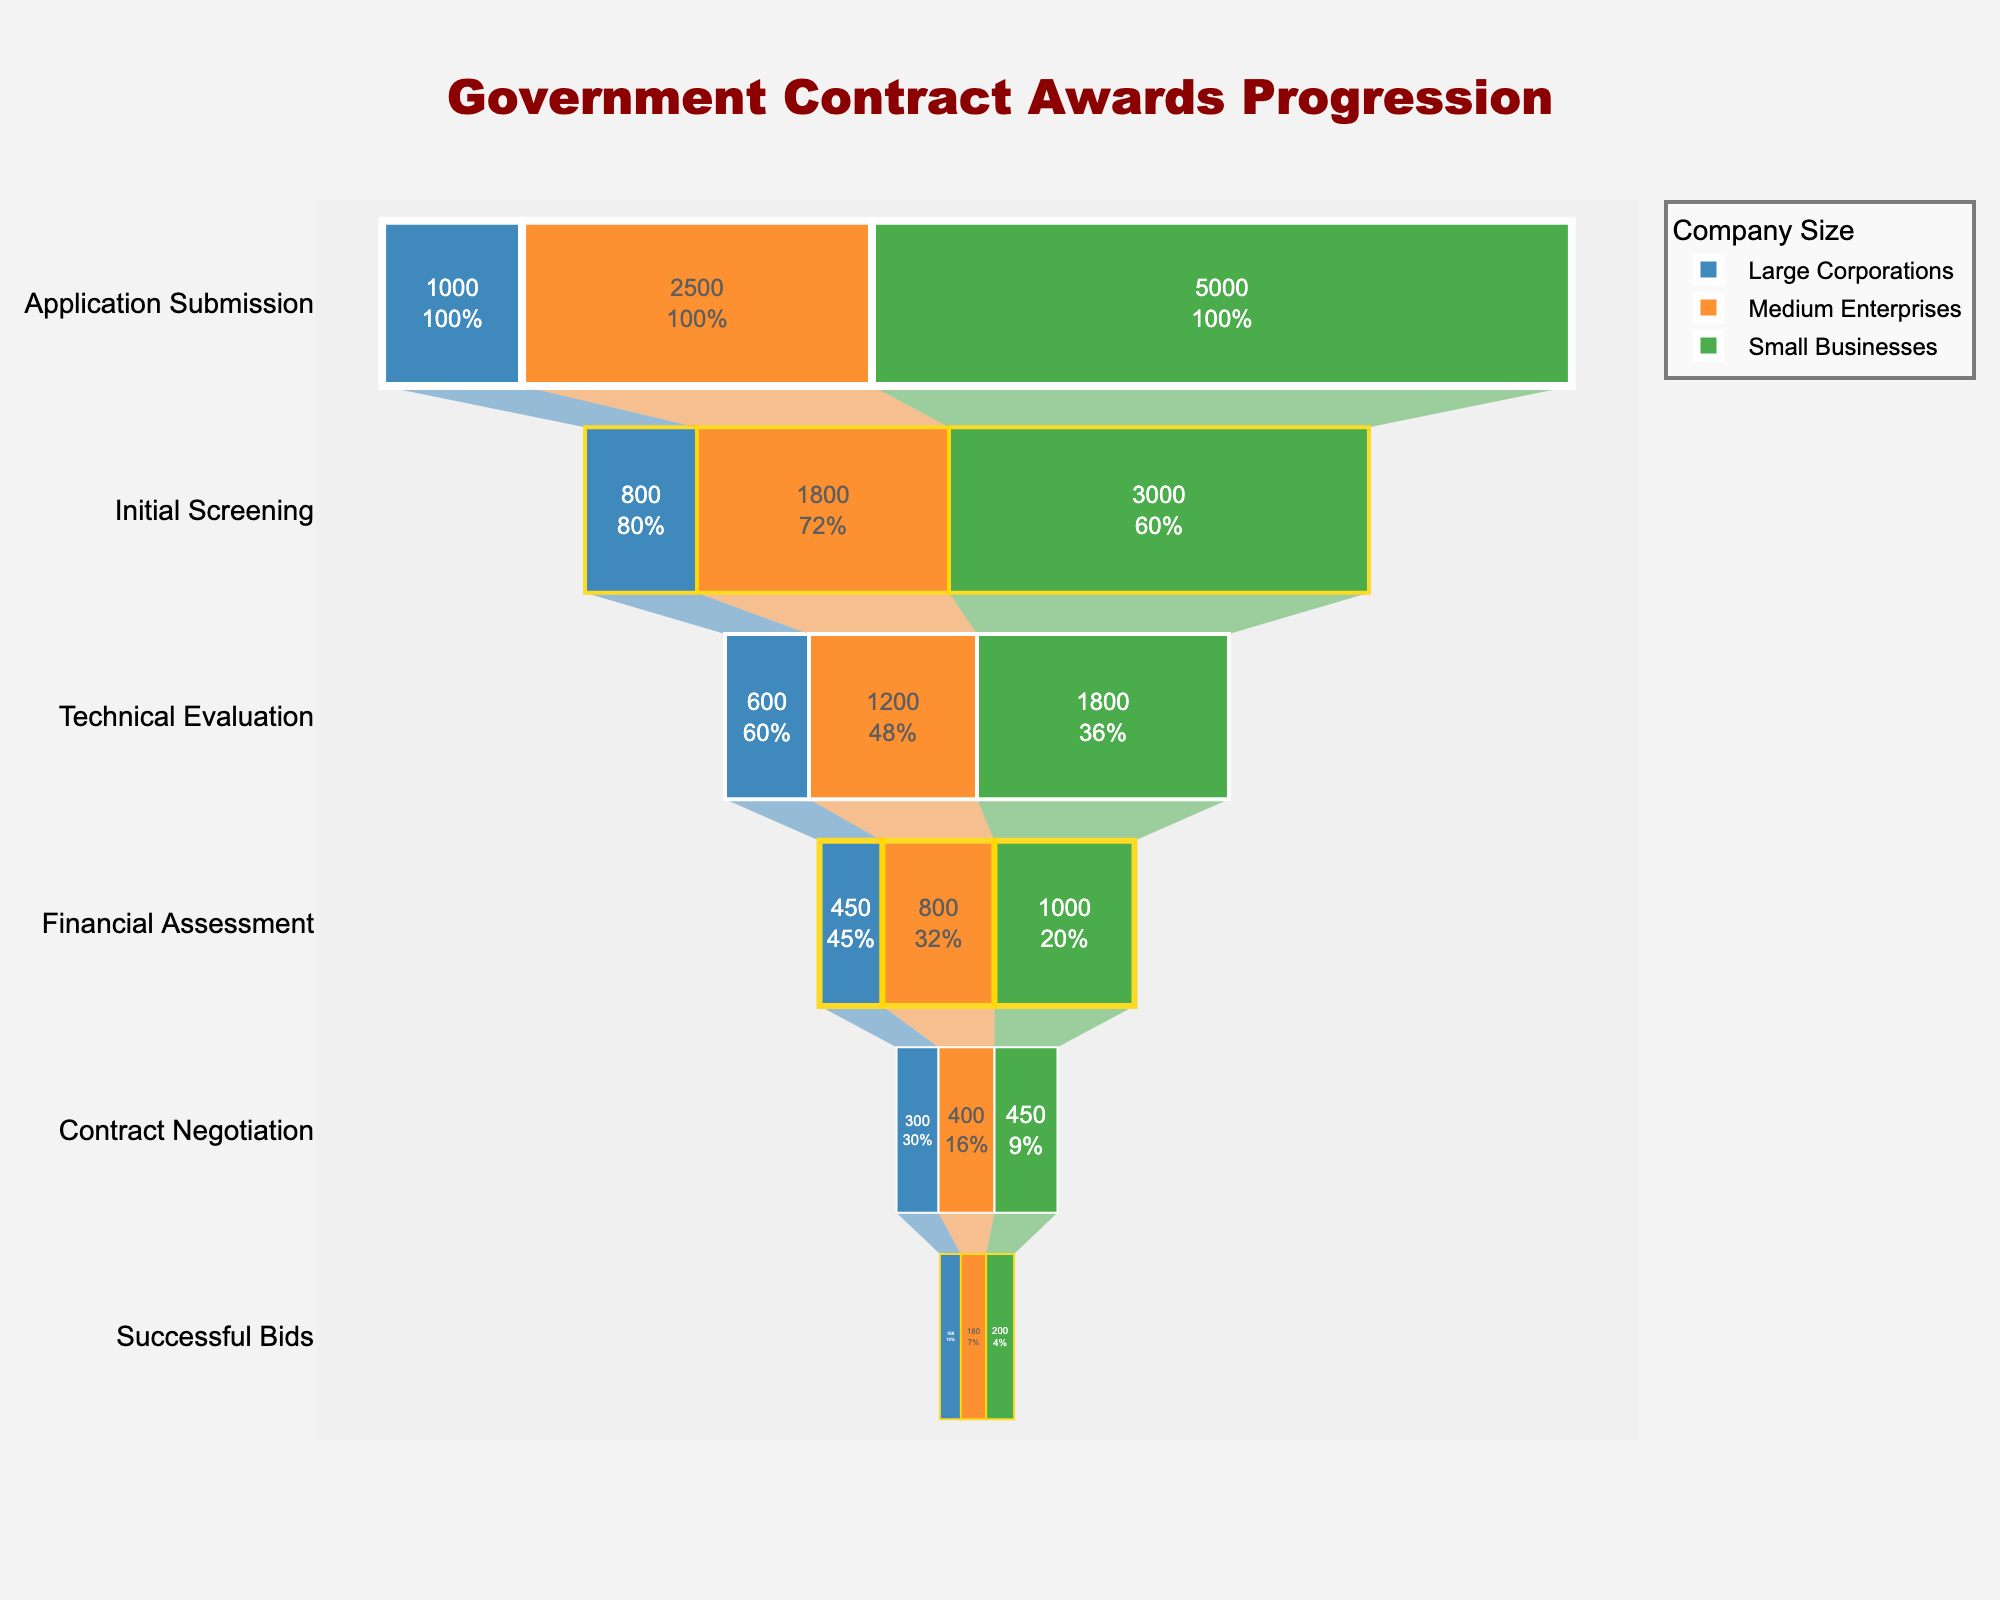What is the title of the figure? The title of the figure is displayed at the top of the chart and reads "Government Contract Awards Progression" as mentioned in the configuration details.
Answer: Government Contract Awards Progression How many stages are displayed in the funnel chart? By observing the figure, we can see there are six stages displayed in the funnel: Application Submission, Initial Screening, Technical Evaluation, Financial Assessment, Contract Negotiation, and Successful Bids.
Answer: Six Which company size has the highest number of successful bids? To find this, we look at the bottom part of the funnel chart where "Successful Bids" are listed. The numbers for Large Corporations (150), Medium Enterprises (180), and Small Businesses (200) indicate that Small Businesses have the highest number of successful bids.
Answer: Small Businesses What percentage of Large Corporations' applications make it to the contract negotiation stage? First, find the number of applications submitted by Large Corporations (1000). Then look at the number that makes it to the "Contract Negotiation" stage (300). The percentage is calculated by (300 / 1000) * 100%.
Answer: 30% How many applications submitted by Medium Enterprises are screened out during the Initial Screening stage? Medium Enterprises submit 2500 applications and 1800 pass the Initial Screening. The number of applications screened out is 2500 - 1800.
Answer: 700 What is the ratio of successful bids to financial assessments for Small Businesses? Look at the numbers for Small Businesses at the "Financial Assessment" stage (1000) and "Successful Bids" stage (200). The ratio is 200 to 1000, which simplifies to 1:5.
Answer: 1:5 How many stages see a greater than 50% reduction in the number of applications for Large Corporations? Calculate the reduction percentage between each pair of successive stages for Large Corporations:  
   - Application Submission -> Initial Screening: (1000 - 800) / 1000 = 20%
   - Initial Screening -> Technical Evaluation: (800 - 600) / 800 = 25%
   - Technical Evaluation -> Financial Assessment: (600 - 450) / 600 = 25%
   - Financial Assessment -> Contract Negotiation: (450 - 300) / 450 = 33%
   - Contract Negotiation -> Successful Bids: (300 - 150) / 300 = 50%  
   Only the transition from Contract Negotiation to Successful Bids sees exactly a 50% reduction, so no transitions see a greater than 50% reduction.
Answer: Zero Between Technical Evaluation and Contract Negotiation stages, which company size has the highest drop-off in absolute numbers? Calculate the drop-off for each company:  
   - Large Corporations: 600 (Technical Evaluation) - 300 (Contract Negotiation) = 300  
   - Medium Enterprises: 1200 (Technical Evaluation) - 400 (Contract Negotiation) = 800  
   - Small Businesses: 1800 (Technical Evaluation) - 450 (Contract Negotiation) = 1350  
   Small Businesses have the highest drop-off in absolute numbers.
Answer: Small Businesses At which stage do Medium Enterprises see the highest percentage reduction in the number of applications? - Application Submission to Initial Screening: (2500 - 1800) / 2500 = 28%
   - Initial Screening to Technical Evaluation: (1800 - 1200) / 1800 = 33%
   - Technical Evaluation to Financial Assessment: (1200 - 800) / 1200 = 33%
   - Financial Assessment to Contract Negotiation: (800 - 400) / 800 = 50%
   - Contract Negotiation to Successful Bids: (400 - 180) / 400 = 55%
   The highest percentage reduction for Medium Enterprises occurs between Contract Negotiation and Successful Bids stages (55%).
Answer: Contract Negotiation to Successful Bids How do the total numbers of submissions for all company sizes compare at the Application Submission stage? Sum the submissions at the Application Submission stage for each company size (Large Corporations: 1000, Medium Enterprises: 2500, Small Businesses: 5000). The total is 1000 + 2500 + 5000.
Answer: 8500 